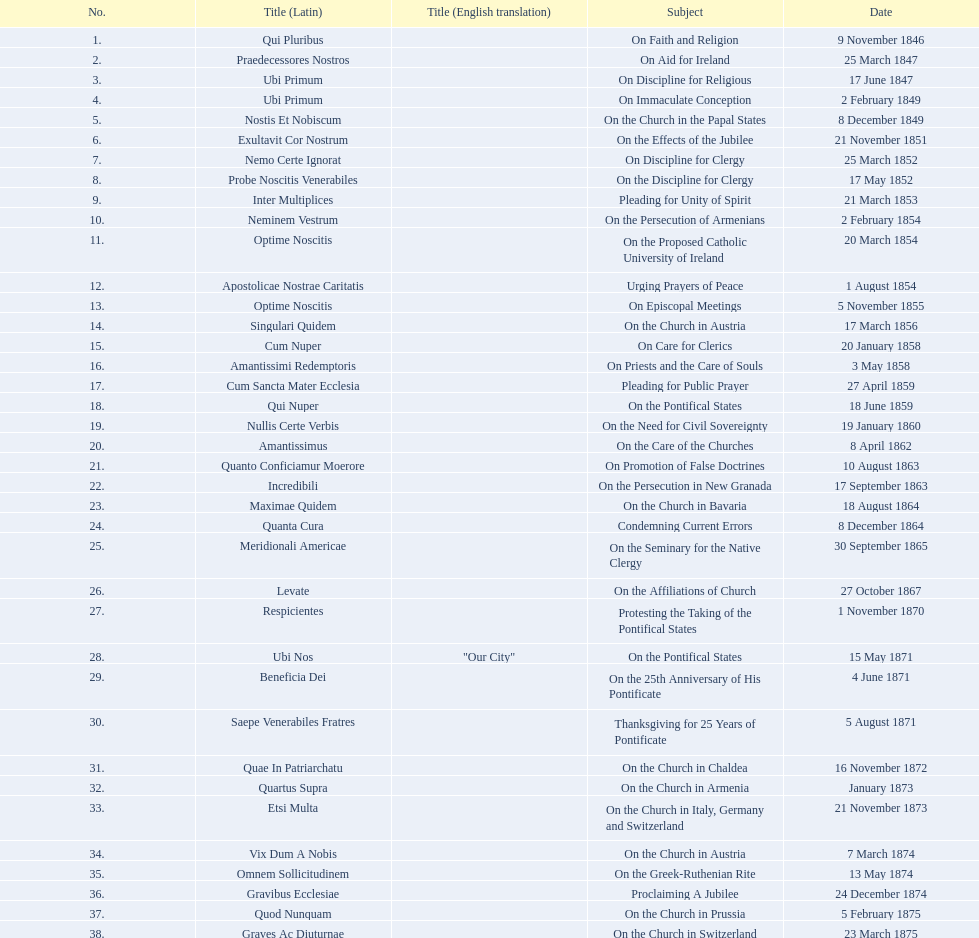What is the latin name of the encyclical prior to the one addressing "on the church in bavaria"? Incredibili. 